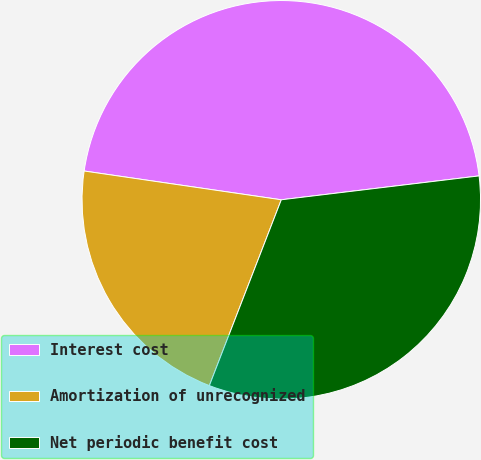<chart> <loc_0><loc_0><loc_500><loc_500><pie_chart><fcel>Interest cost<fcel>Amortization of unrecognized<fcel>Net periodic benefit cost<nl><fcel>45.78%<fcel>21.43%<fcel>32.79%<nl></chart> 